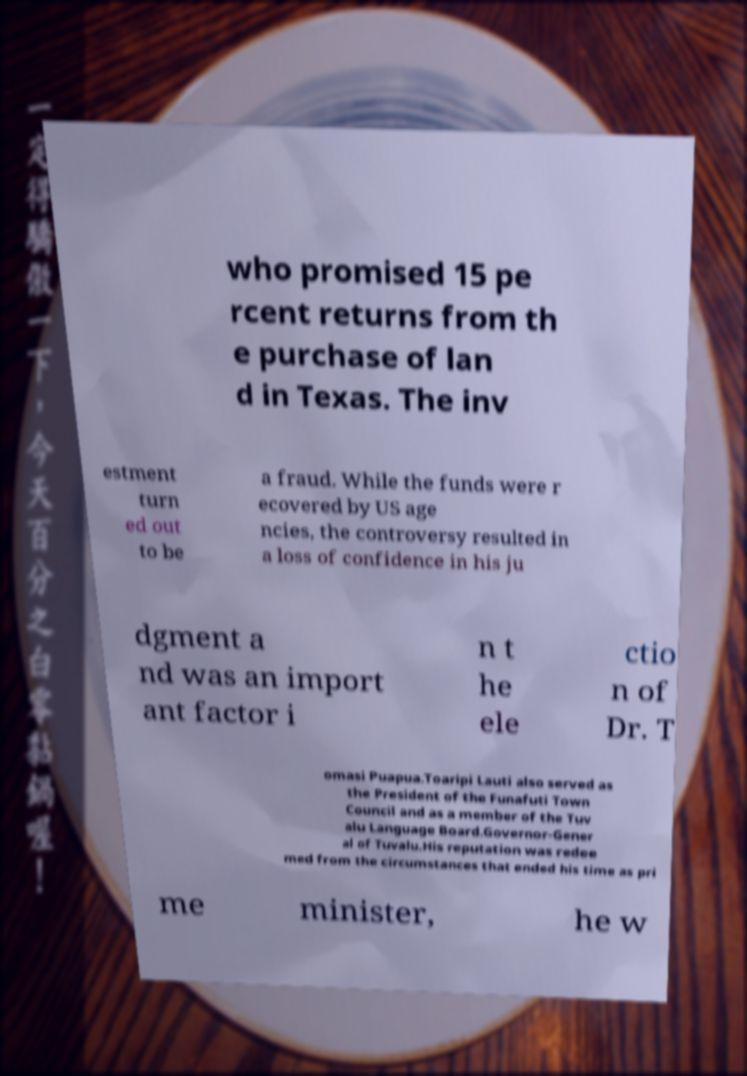Please read and relay the text visible in this image. What does it say? who promised 15 pe rcent returns from th e purchase of lan d in Texas. The inv estment turn ed out to be a fraud. While the funds were r ecovered by US age ncies, the controversy resulted in a loss of confidence in his ju dgment a nd was an import ant factor i n t he ele ctio n of Dr. T omasi Puapua.Toaripi Lauti also served as the President of the Funafuti Town Council and as a member of the Tuv alu Language Board.Governor-Gener al of Tuvalu.His reputation was redee med from the circumstances that ended his time as pri me minister, he w 